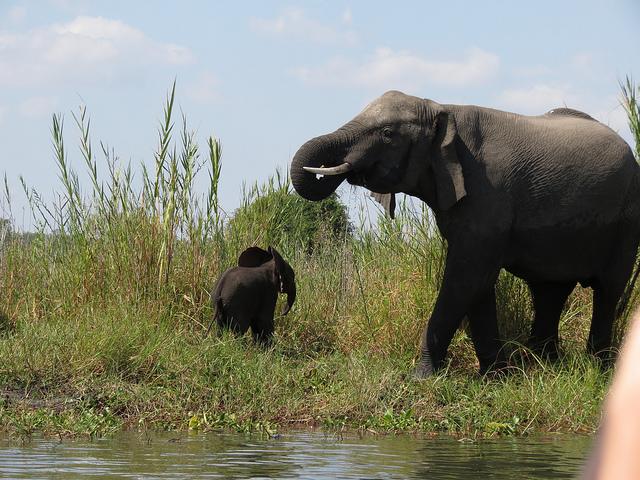How many elephants are male?
Concise answer only. 1. Is the grass taller than the baby?
Be succinct. Yes. Is this a forest?
Write a very short answer. No. Is there a baby present?
Give a very brief answer. Yes. How many animals are shown?
Be succinct. 2. 